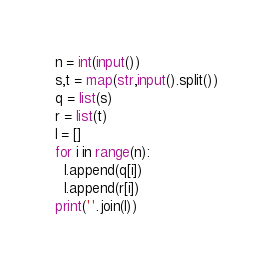<code> <loc_0><loc_0><loc_500><loc_500><_Python_>n = int(input())
s,t = map(str,input().split())
q = list(s)
r = list(t)
l = []
for i in range(n):
  l.append(q[i])
  l.append(r[i])
print(''.join(l))</code> 